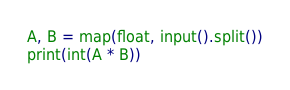Convert code to text. <code><loc_0><loc_0><loc_500><loc_500><_Python_>A, B = map(float, input().split())
print(int(A * B))</code> 